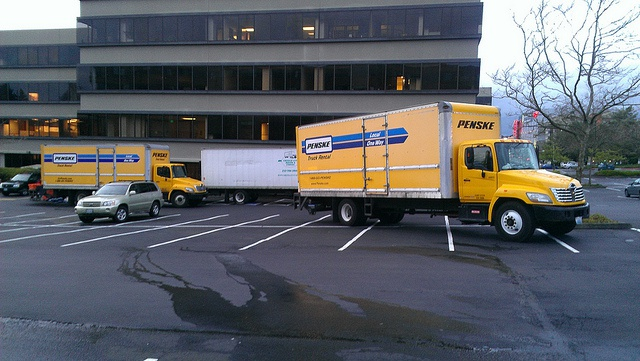Describe the objects in this image and their specific colors. I can see truck in white, black, tan, orange, and darkgray tones, truck in white, tan, black, olive, and darkgray tones, truck in white, lavender, and black tones, car in white, black, gray, darkgray, and lightgray tones, and car in white, black, gray, and blue tones in this image. 